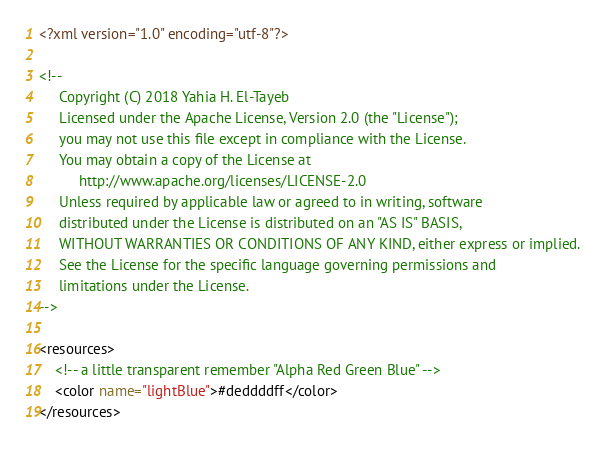Convert code to text. <code><loc_0><loc_0><loc_500><loc_500><_XML_><?xml version="1.0" encoding="utf-8"?>

<!--
     Copyright (C) 2018 Yahia H. El-Tayeb
     Licensed under the Apache License, Version 2.0 (the "License");
     you may not use this file except in compliance with the License.
     You may obtain a copy of the License at
          http://www.apache.org/licenses/LICENSE-2.0
     Unless required by applicable law or agreed to in writing, software
     distributed under the License is distributed on an "AS IS" BASIS,
     WITHOUT WARRANTIES OR CONDITIONS OF ANY KIND, either express or implied.
     See the License for the specific language governing permissions and
     limitations under the License.
-->

<resources>
    <!-- a little transparent remember "Alpha Red Green Blue" -->
    <color name="lightBlue">#deddddff</color>    
</resources>
</code> 